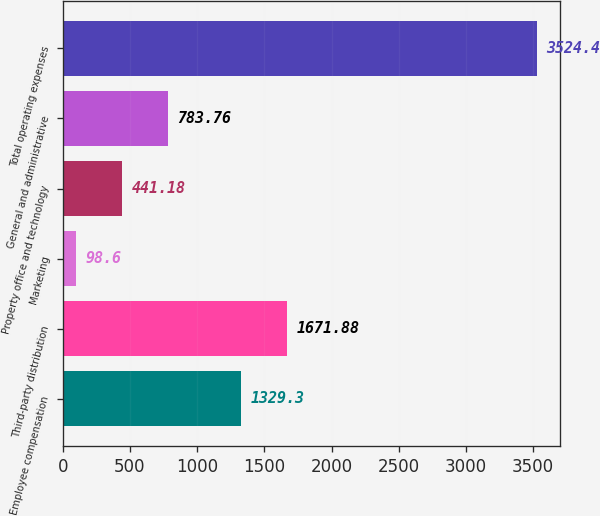Convert chart to OTSL. <chart><loc_0><loc_0><loc_500><loc_500><bar_chart><fcel>Employee compensation<fcel>Third-party distribution<fcel>Marketing<fcel>Property office and technology<fcel>General and administrative<fcel>Total operating expenses<nl><fcel>1329.3<fcel>1671.88<fcel>98.6<fcel>441.18<fcel>783.76<fcel>3524.4<nl></chart> 